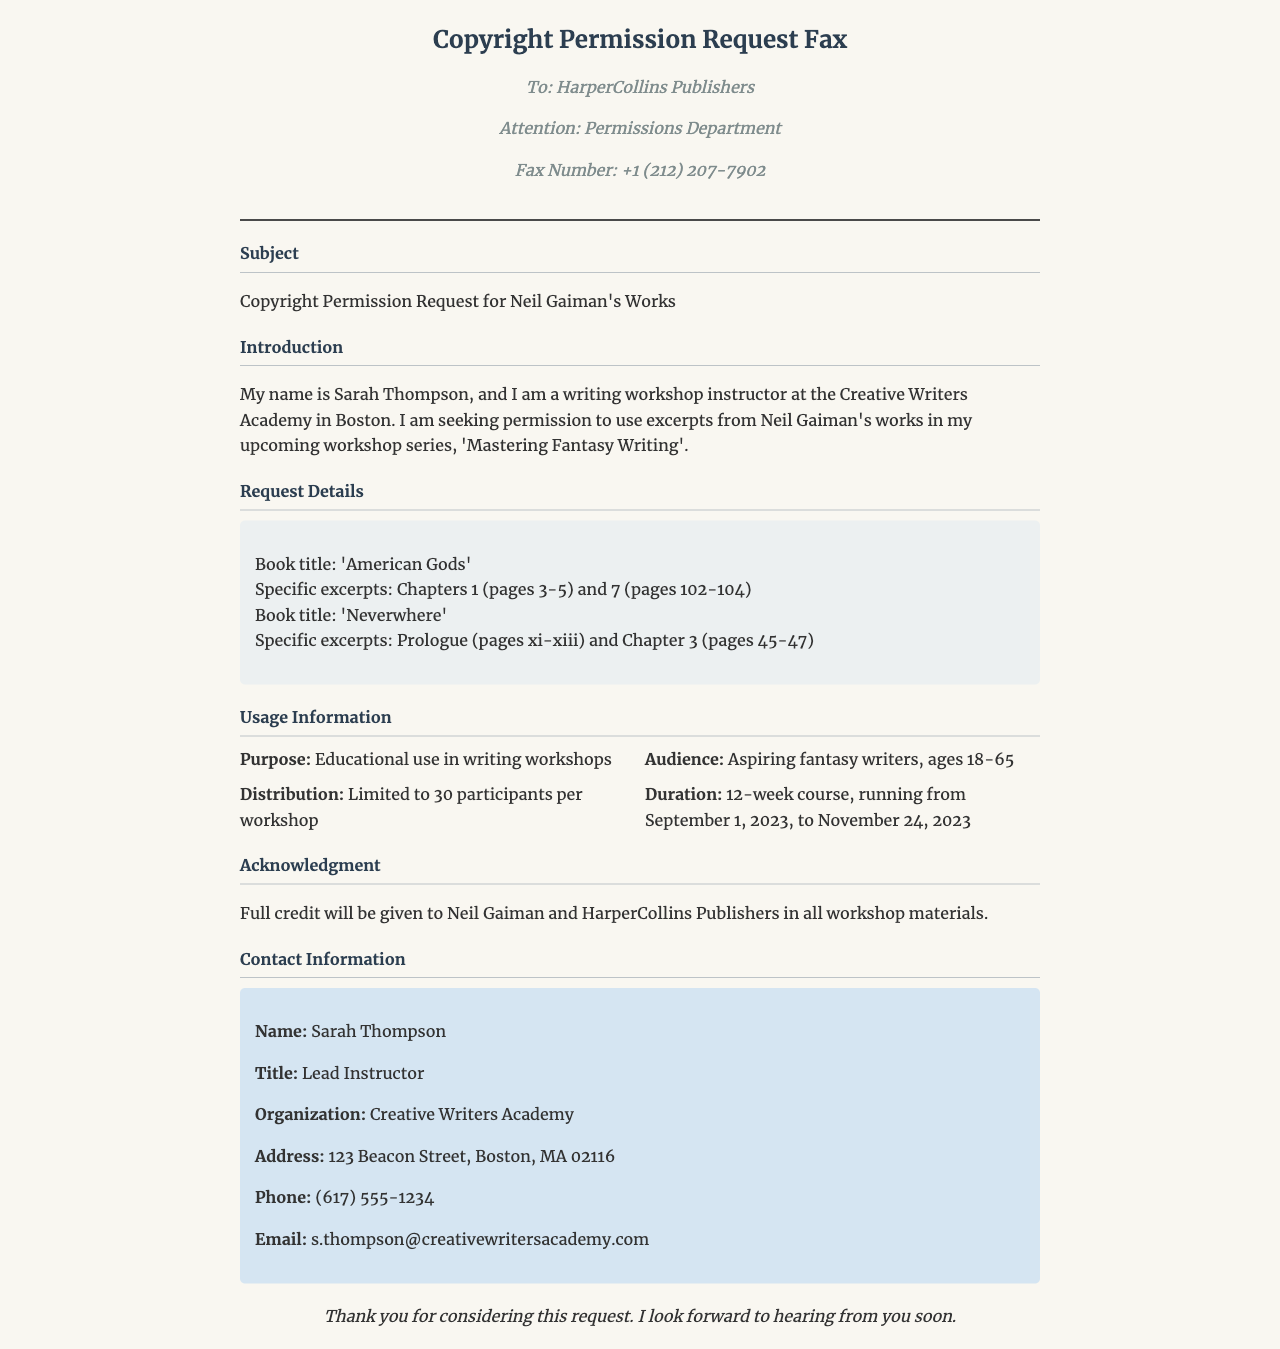What is the title of the workshop series? The title of the workshop series is mentioned in the introduction section of the document.
Answer: Mastering Fantasy Writing Who is the author of the works for which permission is requested? The author of the works is stated in the subject line of the document.
Answer: Neil Gaiman What is the fax number for the Permissions Department? The fax number for the Permissions Department is provided in the fax meta section.
Answer: +1 (212) 207-7902 How many participants are allowed per workshop? The maximum number of participants per workshop is specified in the usage information section.
Answer: 30 What is the duration of the writing course? The duration of the course is indicated in the usage information section and spans a specific time frame.
Answer: 12-week course What is the purpose of using excerpts from Neil Gaiman's works? The purpose is mentioned in the usage information section of the document.
Answer: Educational use in writing workshops What will be given in all workshop materials? The acknowledgment section describes what will be provided in the materials.
Answer: Full credit to Neil Gaiman and HarperCollins Publishers What is the email address provided for contact? The email address is listed under the contact information section.
Answer: s.thompson@creativewritersacademy.com 